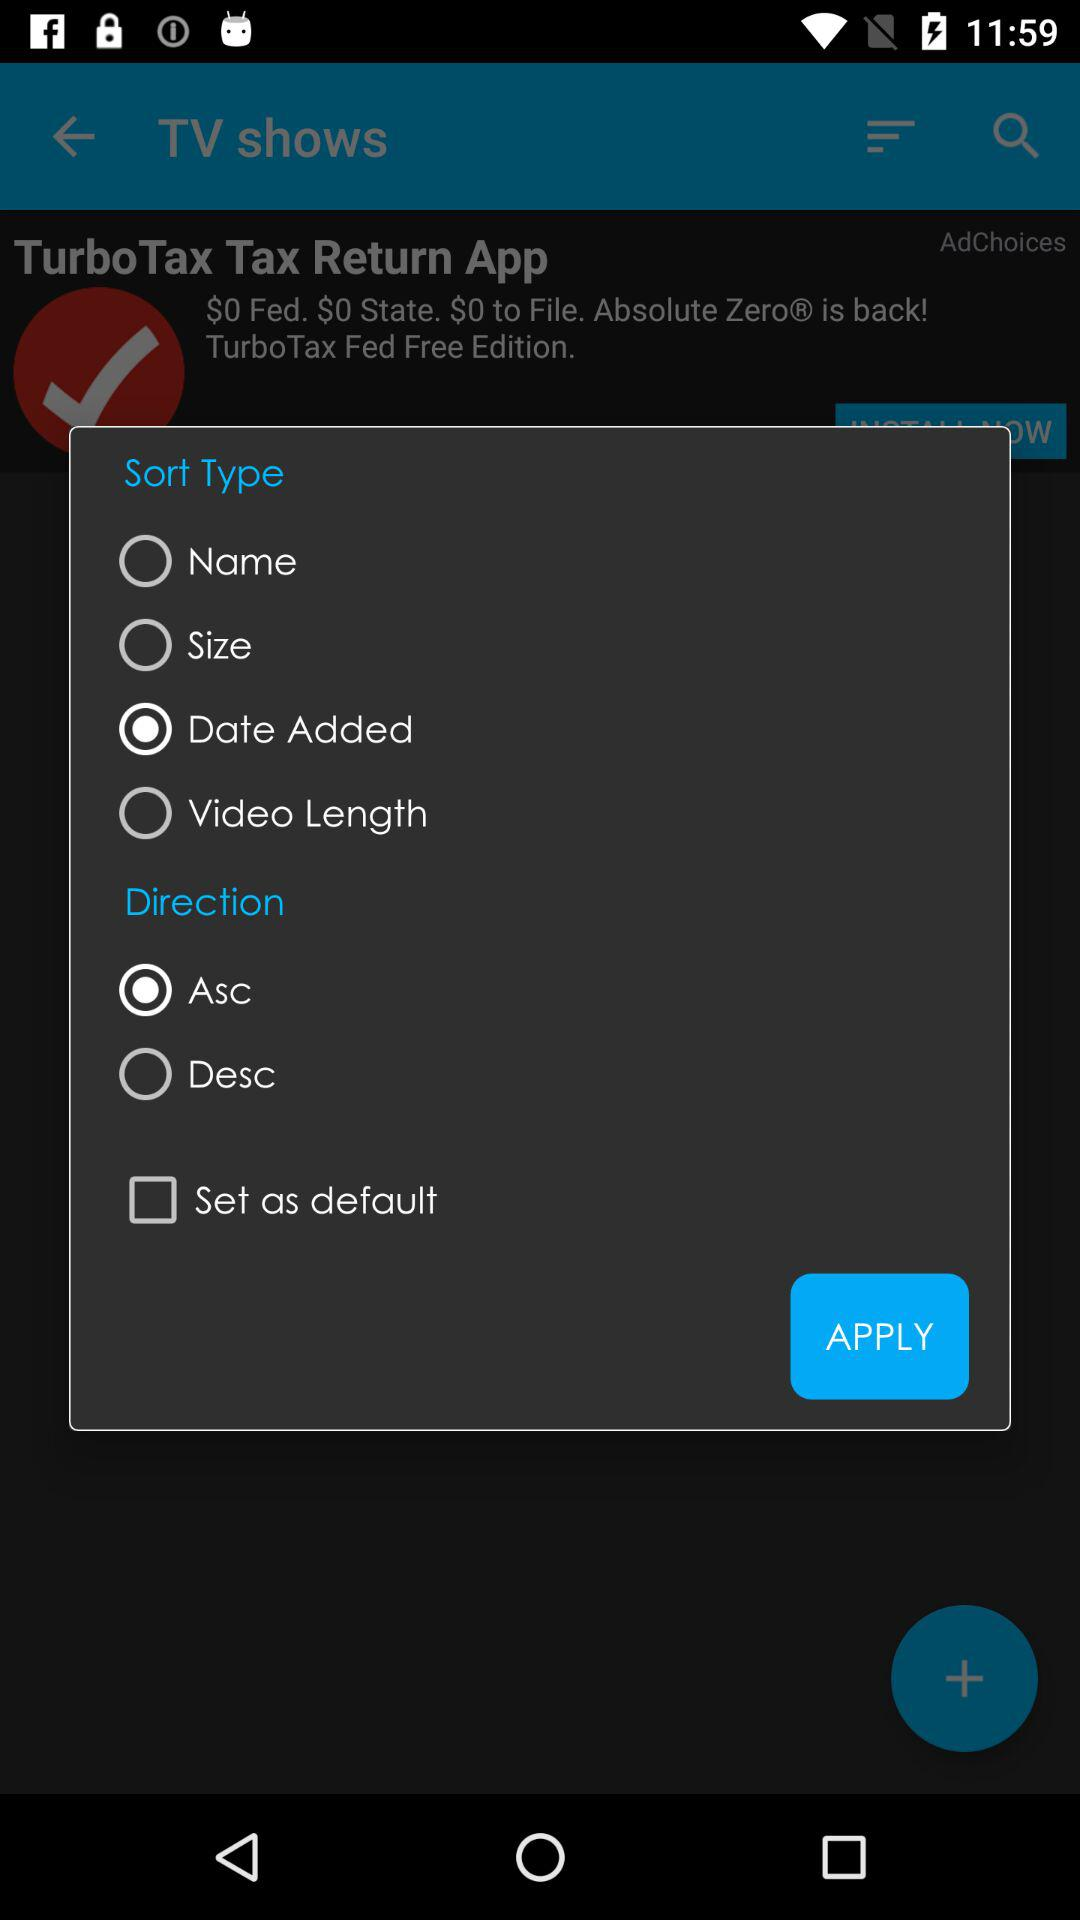What is the option selected for "Direction"? The selected option is "Asc". 